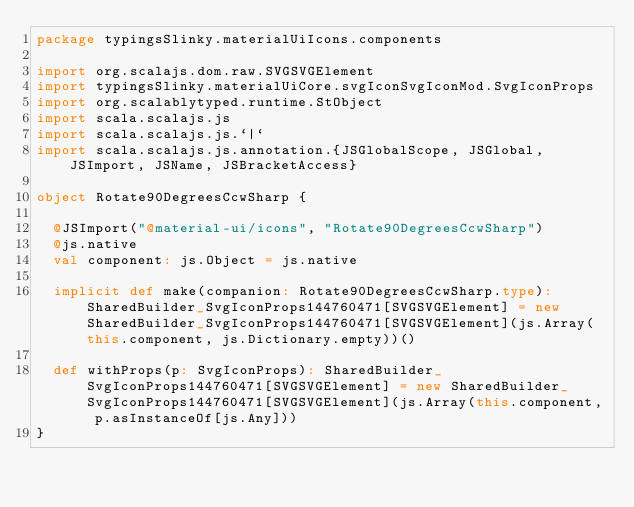Convert code to text. <code><loc_0><loc_0><loc_500><loc_500><_Scala_>package typingsSlinky.materialUiIcons.components

import org.scalajs.dom.raw.SVGSVGElement
import typingsSlinky.materialUiCore.svgIconSvgIconMod.SvgIconProps
import org.scalablytyped.runtime.StObject
import scala.scalajs.js
import scala.scalajs.js.`|`
import scala.scalajs.js.annotation.{JSGlobalScope, JSGlobal, JSImport, JSName, JSBracketAccess}

object Rotate90DegreesCcwSharp {
  
  @JSImport("@material-ui/icons", "Rotate90DegreesCcwSharp")
  @js.native
  val component: js.Object = js.native
  
  implicit def make(companion: Rotate90DegreesCcwSharp.type): SharedBuilder_SvgIconProps144760471[SVGSVGElement] = new SharedBuilder_SvgIconProps144760471[SVGSVGElement](js.Array(this.component, js.Dictionary.empty))()
  
  def withProps(p: SvgIconProps): SharedBuilder_SvgIconProps144760471[SVGSVGElement] = new SharedBuilder_SvgIconProps144760471[SVGSVGElement](js.Array(this.component, p.asInstanceOf[js.Any]))
}
</code> 